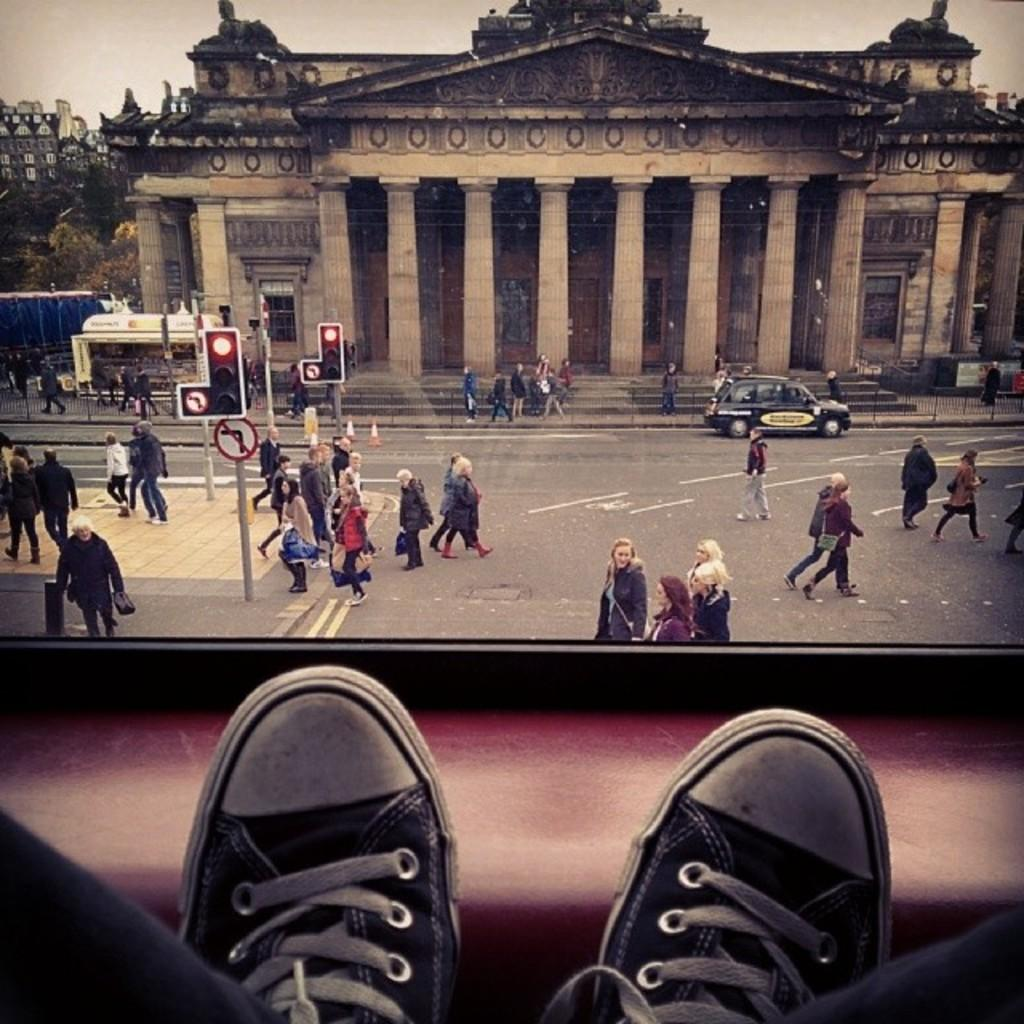What type of footwear can be seen in the image? There is footwear visible in the image. What are the people in the image doing? There are people walking in the image. Can you describe the structure with boards on poles? There are boards on poles in the image. What can be seen on the road in the image? There is a car on the road in the image. What is visible in the background of the image? There are buildings, pillars, trees, and the sky visible in the background of the image. How many giants are holding the buildings in the image? There are no giants present in the image; the buildings are standing on their own. What type of shape do the clocks have in the image? There are no clocks visible in the image. 